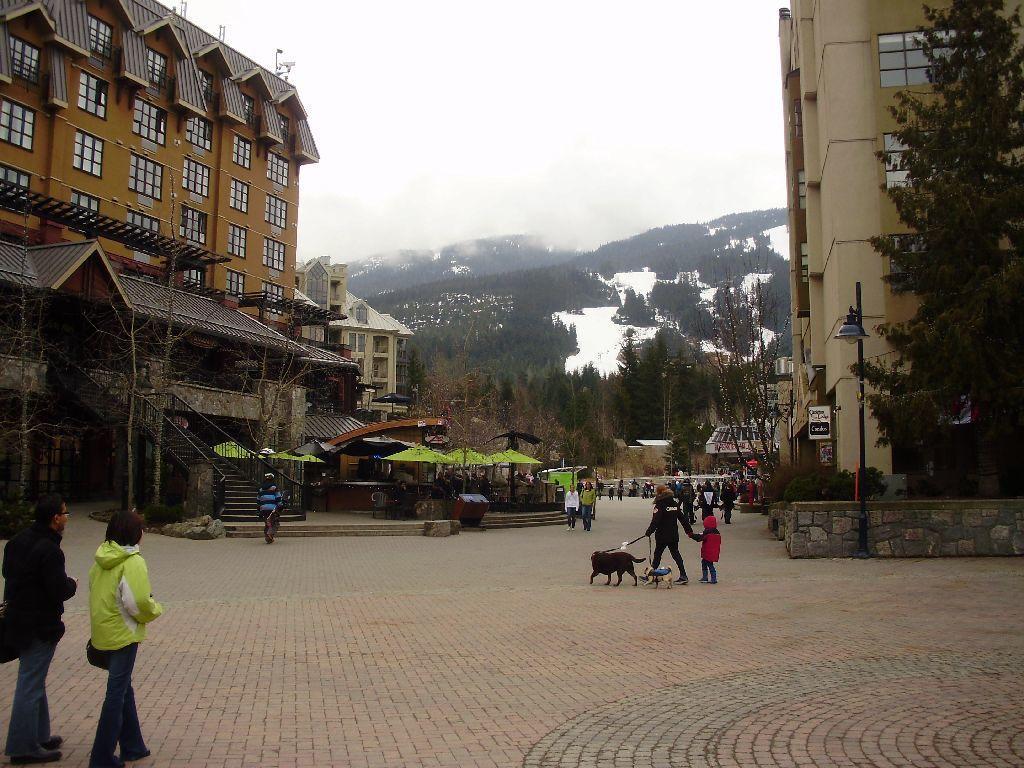How would you summarize this image in a sentence or two? In this image there is a floor in the bottom of this image and there are some persons standing in middle of this image and there are some persons in the bottom left corner of this image. There are some buildings on the left side of this image and on the right side of this image as well. There are some trees in the background. There are some hills on the top of this image and there is a sky on the top side of this hills. 